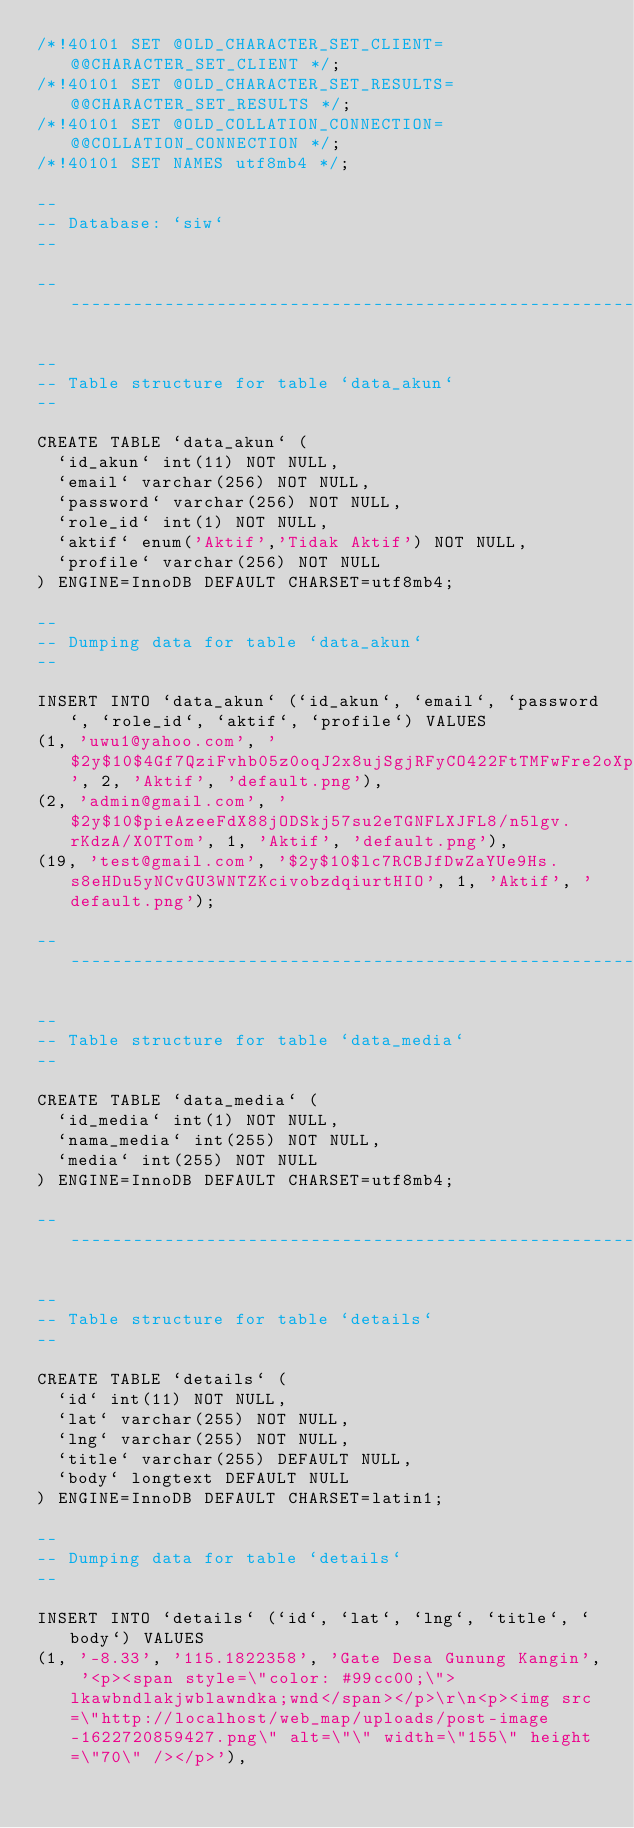Convert code to text. <code><loc_0><loc_0><loc_500><loc_500><_SQL_>/*!40101 SET @OLD_CHARACTER_SET_CLIENT=@@CHARACTER_SET_CLIENT */;
/*!40101 SET @OLD_CHARACTER_SET_RESULTS=@@CHARACTER_SET_RESULTS */;
/*!40101 SET @OLD_COLLATION_CONNECTION=@@COLLATION_CONNECTION */;
/*!40101 SET NAMES utf8mb4 */;

--
-- Database: `siw`
--

-- --------------------------------------------------------

--
-- Table structure for table `data_akun`
--

CREATE TABLE `data_akun` (
  `id_akun` int(11) NOT NULL,
  `email` varchar(256) NOT NULL,
  `password` varchar(256) NOT NULL,
  `role_id` int(1) NOT NULL,
  `aktif` enum('Aktif','Tidak Aktif') NOT NULL,
  `profile` varchar(256) NOT NULL
) ENGINE=InnoDB DEFAULT CHARSET=utf8mb4;

--
-- Dumping data for table `data_akun`
--

INSERT INTO `data_akun` (`id_akun`, `email`, `password`, `role_id`, `aktif`, `profile`) VALUES
(1, 'uwu1@yahoo.com', '$2y$10$4Gf7QziFvhb05z0oqJ2x8ujSgjRFyCO422FtTMFwFre2oXp0aJbnG', 2, 'Aktif', 'default.png'),
(2, 'admin@gmail.com', '$2y$10$pieAzeeFdX88jODSkj57su2eTGNFLXJFL8/n5lgv.rKdzA/X0TTom', 1, 'Aktif', 'default.png'),
(19, 'test@gmail.com', '$2y$10$lc7RCBJfDwZaYUe9Hs.s8eHDu5yNCvGU3WNTZKcivobzdqiurtHIO', 1, 'Aktif', 'default.png');

-- --------------------------------------------------------

--
-- Table structure for table `data_media`
--

CREATE TABLE `data_media` (
  `id_media` int(1) NOT NULL,
  `nama_media` int(255) NOT NULL,
  `media` int(255) NOT NULL
) ENGINE=InnoDB DEFAULT CHARSET=utf8mb4;

-- --------------------------------------------------------

--
-- Table structure for table `details`
--

CREATE TABLE `details` (
  `id` int(11) NOT NULL,
  `lat` varchar(255) NOT NULL,
  `lng` varchar(255) NOT NULL,
  `title` varchar(255) DEFAULT NULL,
  `body` longtext DEFAULT NULL
) ENGINE=InnoDB DEFAULT CHARSET=latin1;

--
-- Dumping data for table `details`
--

INSERT INTO `details` (`id`, `lat`, `lng`, `title`, `body`) VALUES
(1, '-8.33', '115.1822358', 'Gate Desa Gunung Kangin', '<p><span style=\"color: #99cc00;\">lkawbndlakjwblawndka;wnd</span></p>\r\n<p><img src=\"http://localhost/web_map/uploads/post-image-1622720859427.png\" alt=\"\" width=\"155\" height=\"70\" /></p>'),</code> 